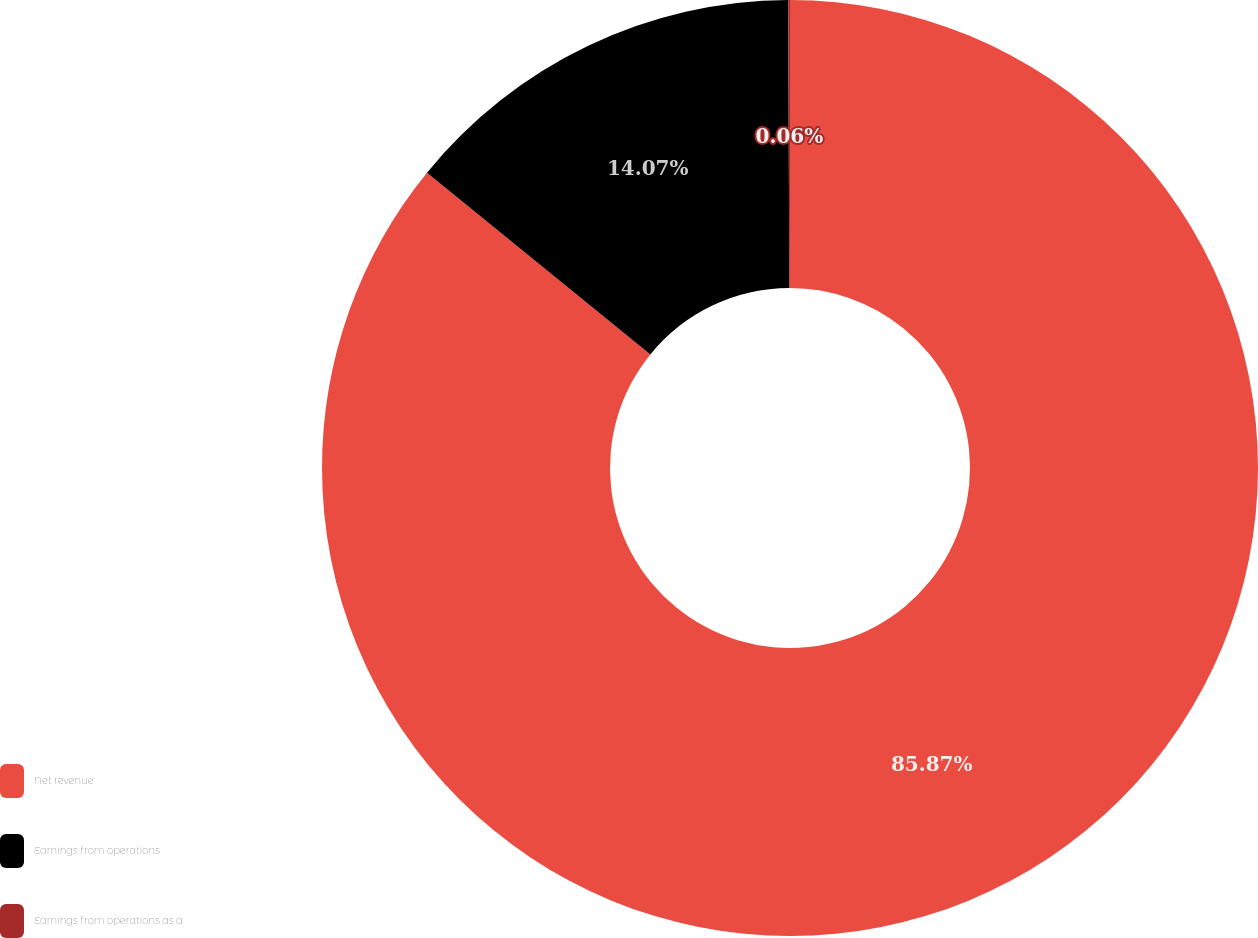Convert chart to OTSL. <chart><loc_0><loc_0><loc_500><loc_500><pie_chart><fcel>Net revenue<fcel>Earnings from operations<fcel>Earnings from operations as a<nl><fcel>85.87%<fcel>14.07%<fcel>0.06%<nl></chart> 